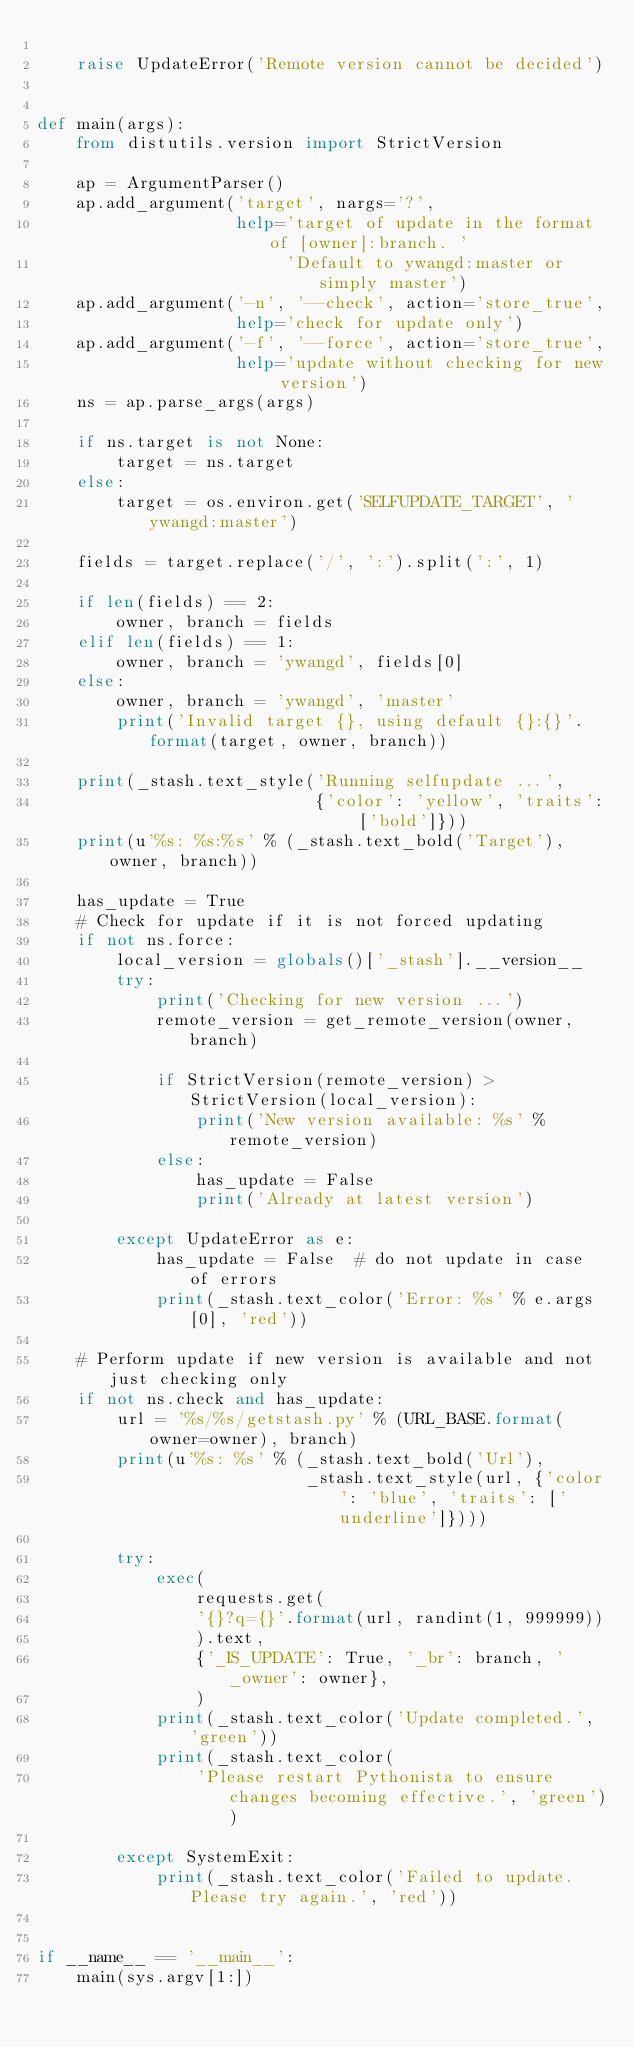Convert code to text. <code><loc_0><loc_0><loc_500><loc_500><_Python_>
    raise UpdateError('Remote version cannot be decided')


def main(args):
    from distutils.version import StrictVersion

    ap = ArgumentParser()
    ap.add_argument('target', nargs='?',
                    help='target of update in the format of [owner]:branch. '
                         'Default to ywangd:master or simply master')
    ap.add_argument('-n', '--check', action='store_true',
                    help='check for update only')
    ap.add_argument('-f', '--force', action='store_true',
                    help='update without checking for new version')
    ns = ap.parse_args(args)

    if ns.target is not None:
        target = ns.target
    else:
        target = os.environ.get('SELFUPDATE_TARGET', 'ywangd:master')

    fields = target.replace('/', ':').split(':', 1)

    if len(fields) == 2:
        owner, branch = fields
    elif len(fields) == 1:
        owner, branch = 'ywangd', fields[0]
    else:
        owner, branch = 'ywangd', 'master'
        print('Invalid target {}, using default {}:{}'.format(target, owner, branch))

    print(_stash.text_style('Running selfupdate ...',
                            {'color': 'yellow', 'traits': ['bold']}))
    print(u'%s: %s:%s' % (_stash.text_bold('Target'), owner, branch))

    has_update = True
    # Check for update if it is not forced updating
    if not ns.force:
        local_version = globals()['_stash'].__version__
        try:
            print('Checking for new version ...')
            remote_version = get_remote_version(owner, branch)

            if StrictVersion(remote_version) > StrictVersion(local_version):
                print('New version available: %s' % remote_version)
            else:
                has_update = False
                print('Already at latest version')

        except UpdateError as e:
            has_update = False  # do not update in case of errors
            print(_stash.text_color('Error: %s' % e.args[0], 'red'))

    # Perform update if new version is available and not just checking only
    if not ns.check and has_update:
        url = '%s/%s/getstash.py' % (URL_BASE.format(owner=owner), branch)
        print(u'%s: %s' % (_stash.text_bold('Url'),
                           _stash.text_style(url, {'color': 'blue', 'traits': ['underline']})))

        try:
            exec(
            	requests.get(
                '{}?q={}'.format(url, randint(1, 999999))
                ).text,
                {'_IS_UPDATE': True, '_br': branch, '_owner': owner},
                )
            print(_stash.text_color('Update completed.', 'green'))
            print(_stash.text_color(
                'Please restart Pythonista to ensure changes becoming effective.', 'green'))

        except SystemExit:
            print(_stash.text_color('Failed to update. Please try again.', 'red'))


if __name__ == '__main__':
    main(sys.argv[1:])</code> 